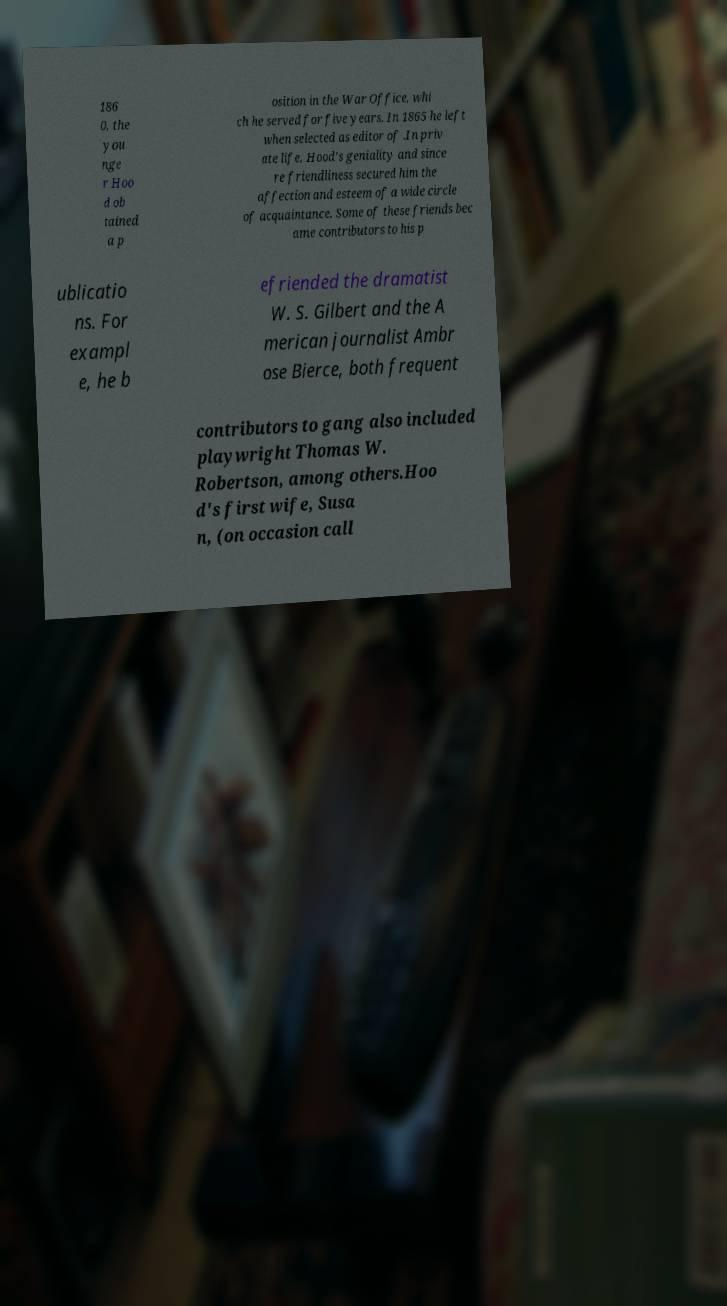I need the written content from this picture converted into text. Can you do that? 186 0, the you nge r Hoo d ob tained a p osition in the War Office, whi ch he served for five years. In 1865 he left when selected as editor of .In priv ate life, Hood's geniality and since re friendliness secured him the affection and esteem of a wide circle of acquaintance. Some of these friends bec ame contributors to his p ublicatio ns. For exampl e, he b efriended the dramatist W. S. Gilbert and the A merican journalist Ambr ose Bierce, both frequent contributors to gang also included playwright Thomas W. Robertson, among others.Hoo d's first wife, Susa n, (on occasion call 